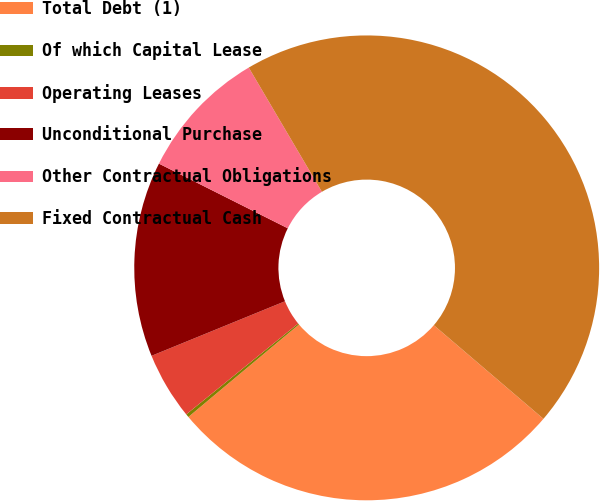Convert chart. <chart><loc_0><loc_0><loc_500><loc_500><pie_chart><fcel>Total Debt (1)<fcel>Of which Capital Lease<fcel>Operating Leases<fcel>Unconditional Purchase<fcel>Other Contractual Obligations<fcel>Fixed Contractual Cash<nl><fcel>27.67%<fcel>0.23%<fcel>4.68%<fcel>13.58%<fcel>9.13%<fcel>44.73%<nl></chart> 